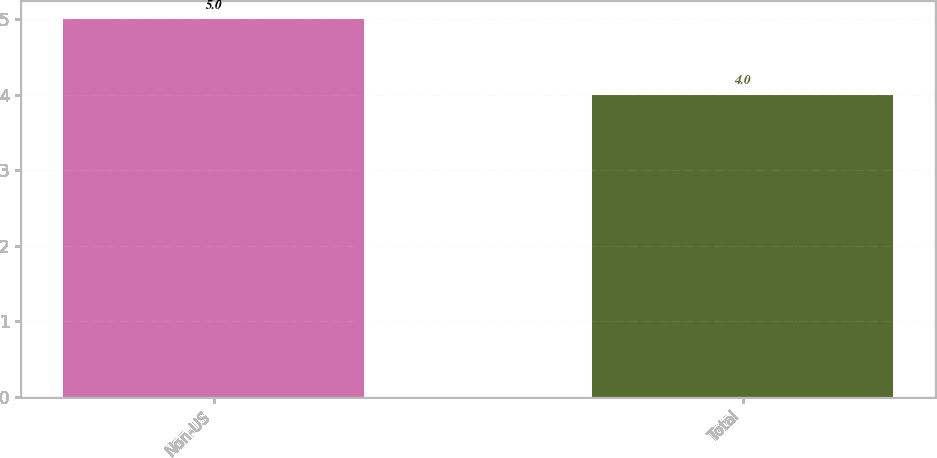Convert chart. <chart><loc_0><loc_0><loc_500><loc_500><bar_chart><fcel>Non-US<fcel>Total<nl><fcel>5<fcel>4<nl></chart> 